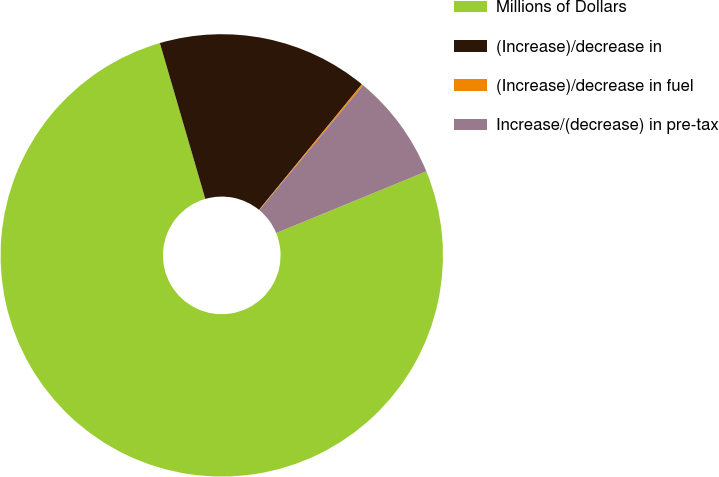<chart> <loc_0><loc_0><loc_500><loc_500><pie_chart><fcel>Millions of Dollars<fcel>(Increase)/decrease in<fcel>(Increase)/decrease in fuel<fcel>Increase/(decrease) in pre-tax<nl><fcel>76.68%<fcel>15.43%<fcel>0.11%<fcel>7.77%<nl></chart> 